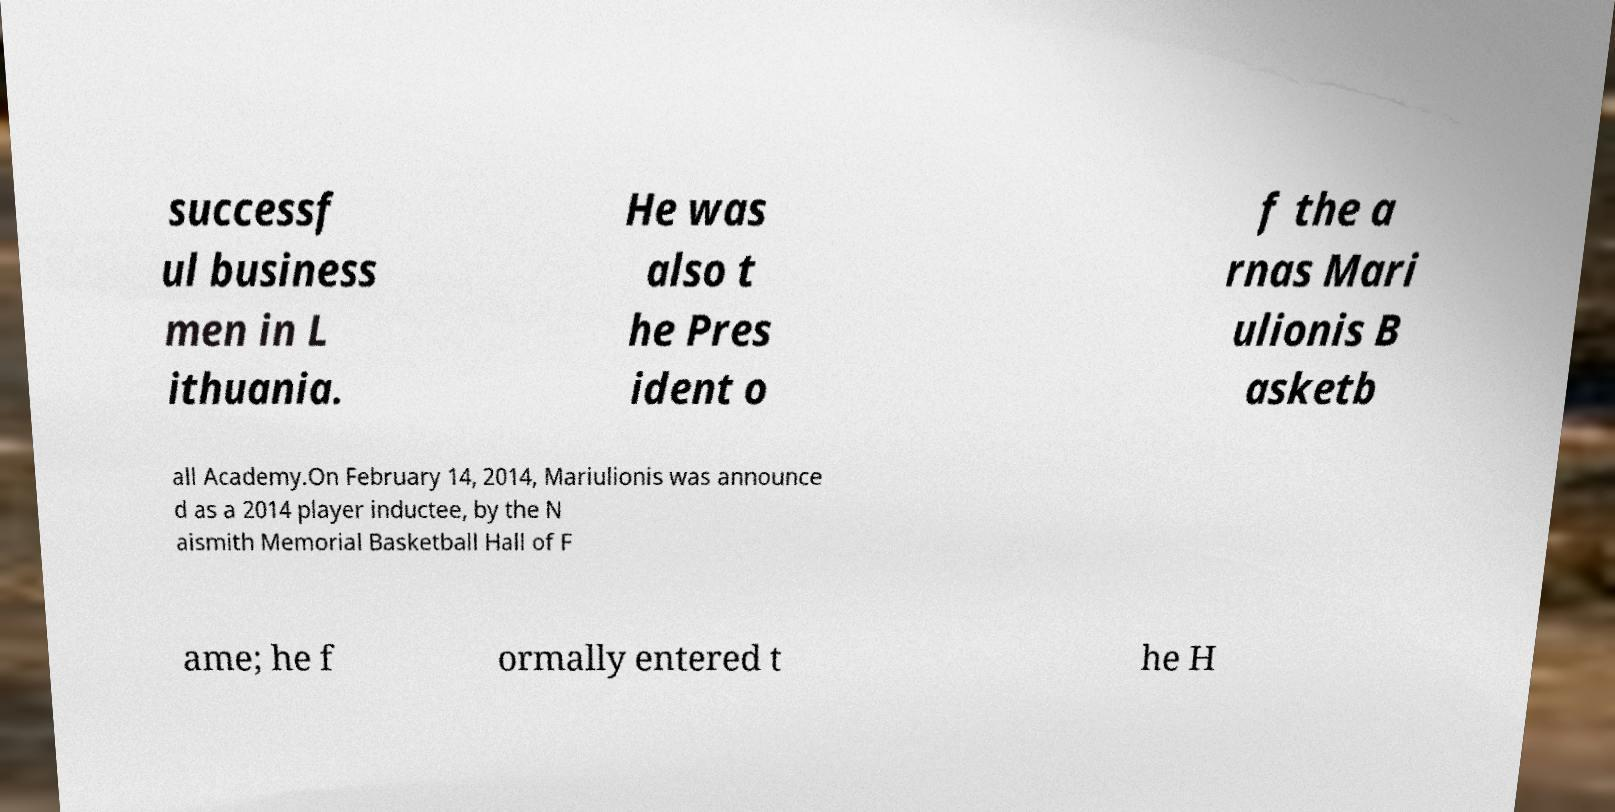For documentation purposes, I need the text within this image transcribed. Could you provide that? successf ul business men in L ithuania. He was also t he Pres ident o f the a rnas Mari ulionis B asketb all Academy.On February 14, 2014, Mariulionis was announce d as a 2014 player inductee, by the N aismith Memorial Basketball Hall of F ame; he f ormally entered t he H 